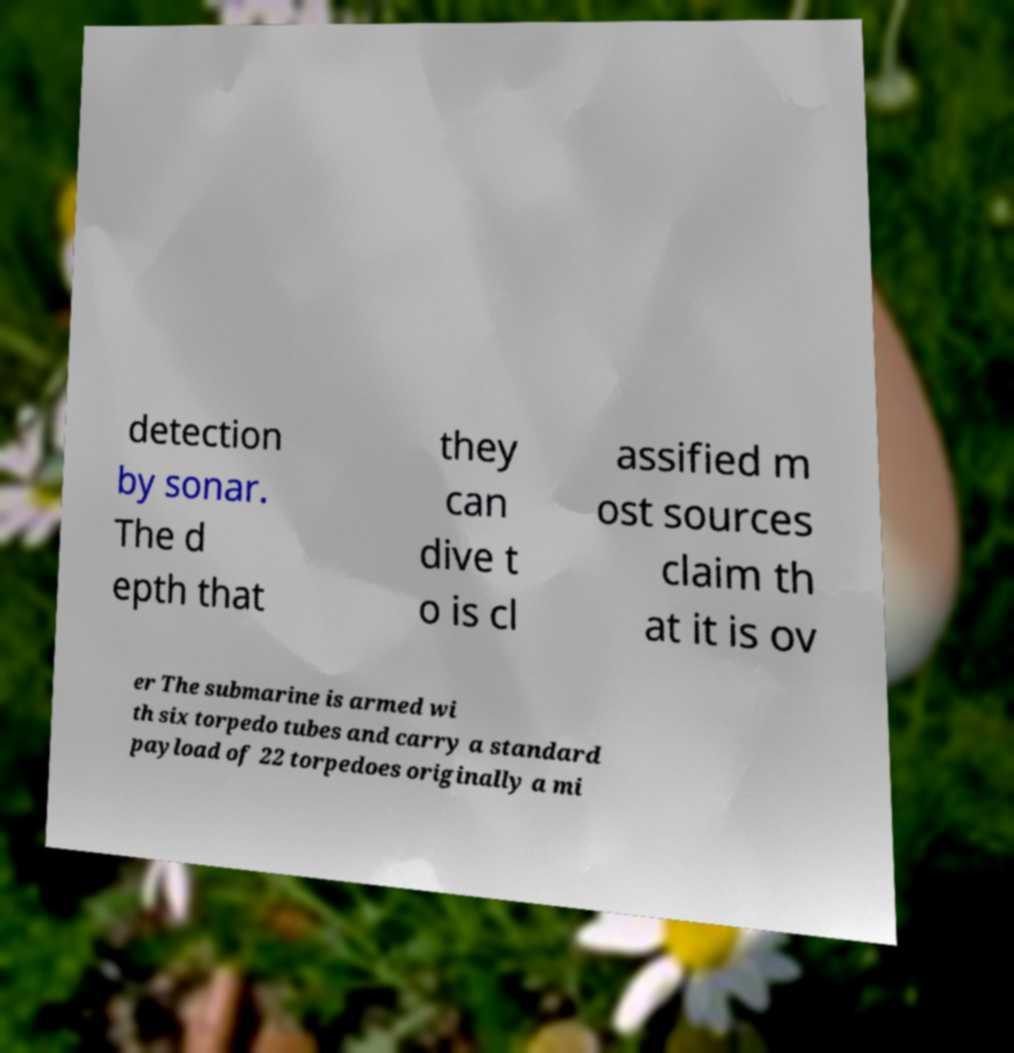There's text embedded in this image that I need extracted. Can you transcribe it verbatim? detection by sonar. The d epth that they can dive t o is cl assified m ost sources claim th at it is ov er The submarine is armed wi th six torpedo tubes and carry a standard payload of 22 torpedoes originally a mi 